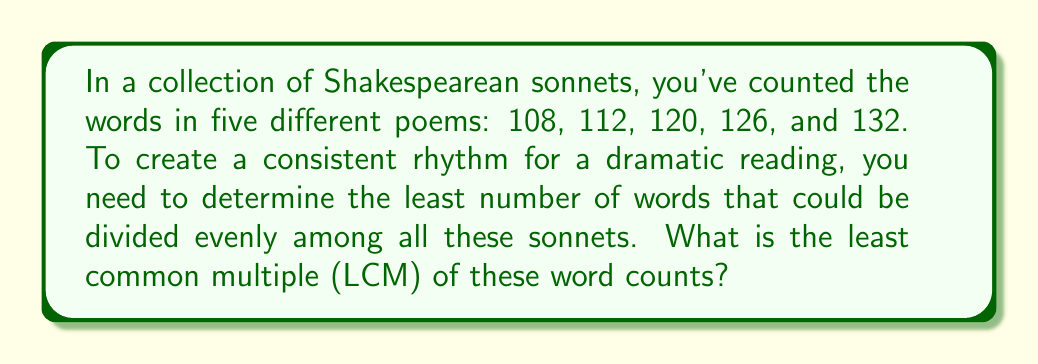Teach me how to tackle this problem. To find the least common multiple (LCM) of 108, 112, 120, 126, and 132, we'll follow these steps:

1. First, let's factor each number:
   $108 = 2^2 \times 3^3$
   $112 = 2^4 \times 7$
   $120 = 2^3 \times 3 \times 5$
   $126 = 2 \times 3^2 \times 7$
   $132 = 2^2 \times 3 \times 11$

2. The LCM will include the highest power of each prime factor from all numbers:
   $2^4$ (from 112)
   $3^3$ (from 108)
   $5^1$ (from 120)
   $7^1$ (from 112 and 126)
   $11^1$ (from 132)

3. Multiply these factors:
   $LCM = 2^4 \times 3^3 \times 5 \times 7 \times 11$

4. Calculate the result:
   $LCM = 16 \times 27 \times 5 \times 7 \times 11 = 166,320$

Thus, 166,320 words is the least number that could be divided evenly among all these sonnets, creating a consistent rhythm for the dramatic reading.
Answer: 166,320 